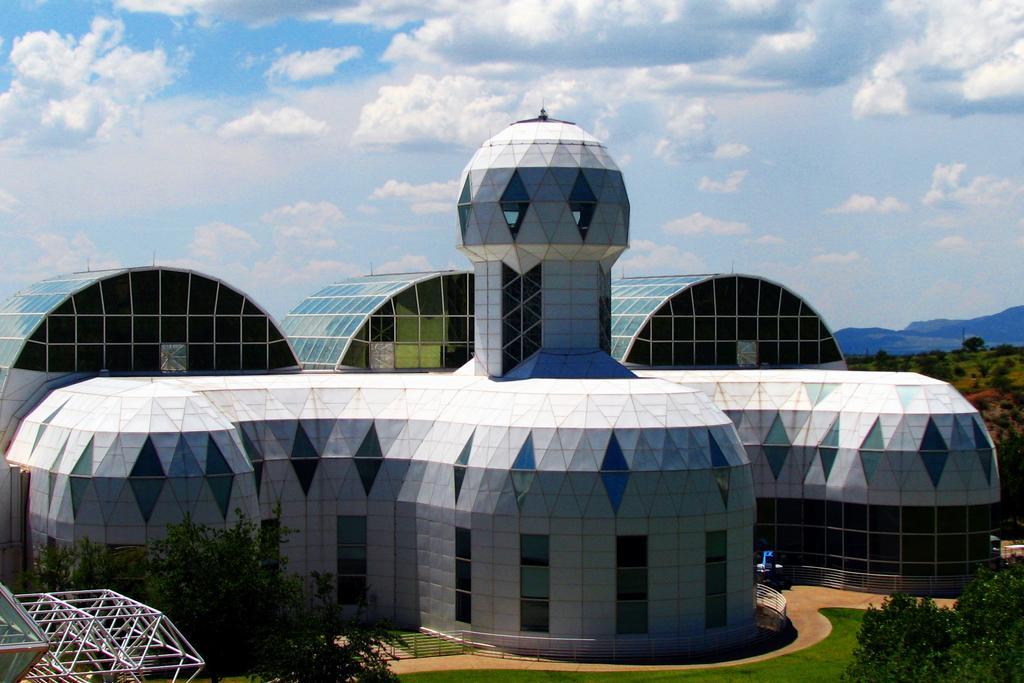Please provide a concise description of this image. In this image in the center there is a building and on the right side and left side there are trees, on the left side there are some objects. And at the bottom there is grass and walkway and railing, and in the background there are mountains and trees. And at the top there is sky. 